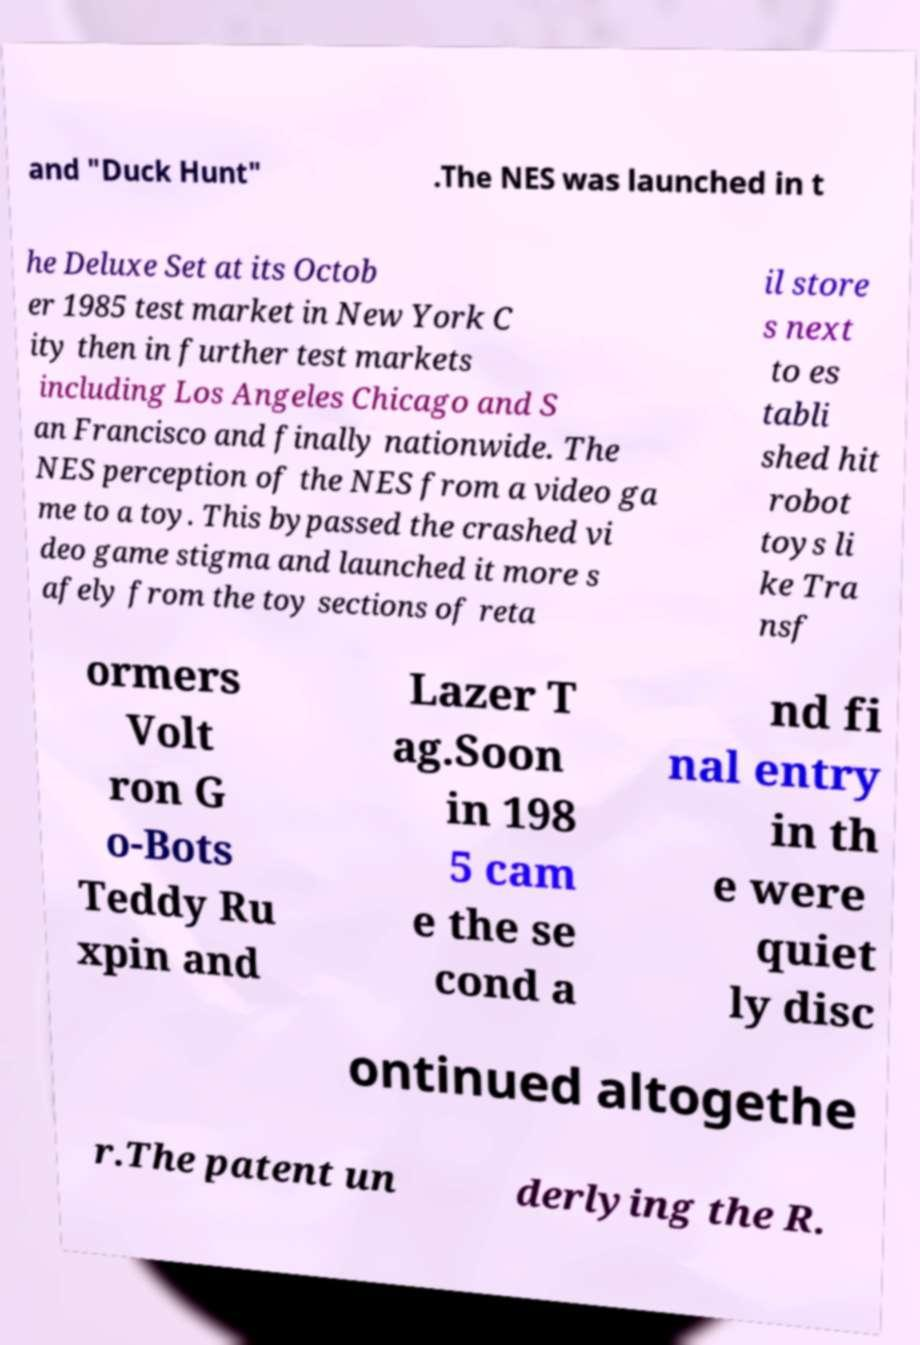Please read and relay the text visible in this image. What does it say? and "Duck Hunt" .The NES was launched in t he Deluxe Set at its Octob er 1985 test market in New York C ity then in further test markets including Los Angeles Chicago and S an Francisco and finally nationwide. The NES perception of the NES from a video ga me to a toy. This bypassed the crashed vi deo game stigma and launched it more s afely from the toy sections of reta il store s next to es tabli shed hit robot toys li ke Tra nsf ormers Volt ron G o-Bots Teddy Ru xpin and Lazer T ag.Soon in 198 5 cam e the se cond a nd fi nal entry in th e were quiet ly disc ontinued altogethe r.The patent un derlying the R. 